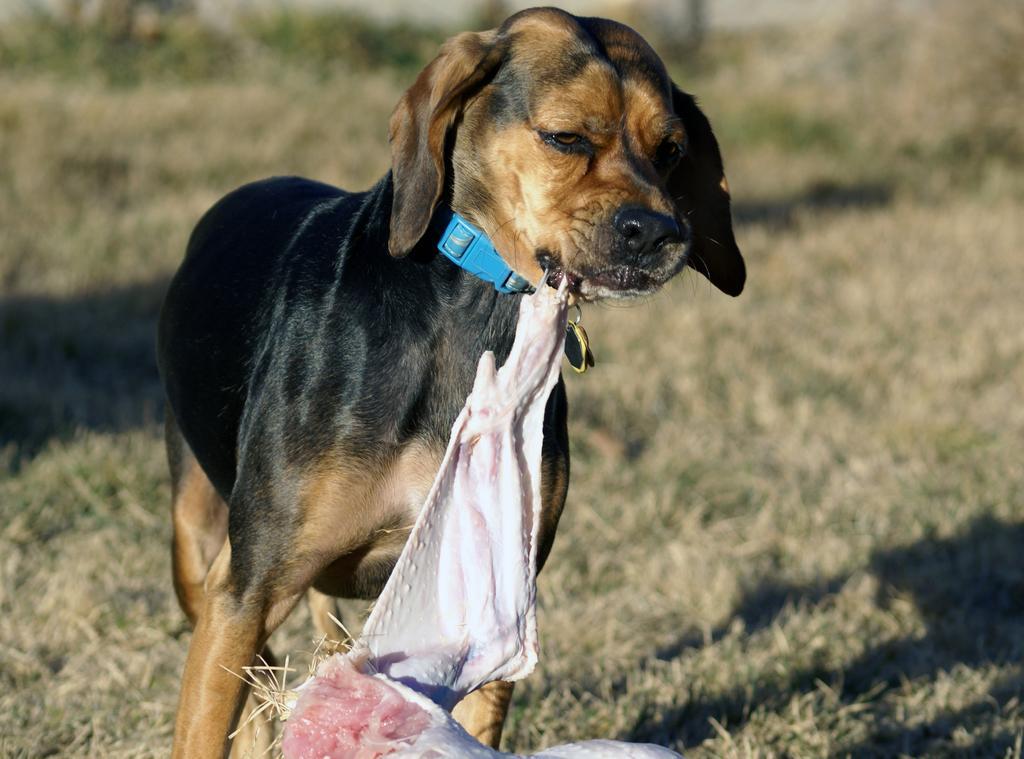Please provide a concise description of this image. In this image we can see a dog is standing, there is a belt to it´s neck and it is holding meat of an animal in it´s mouth. In the background we can see the grass and shadows. 